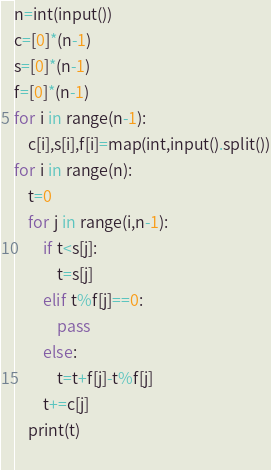Convert code to text. <code><loc_0><loc_0><loc_500><loc_500><_Python_>n=int(input())
c=[0]*(n-1)
s=[0]*(n-1)
f=[0]*(n-1)
for i in range(n-1):
    c[i],s[i],f[i]=map(int,input().split())
for i in range(n):
    t=0
    for j in range(i,n-1):
        if t<s[j]:
            t=s[j]
        elif t%f[j]==0:
            pass
        else:
            t=t+f[j]-t%f[j]
        t+=c[j]
    print(t)
    
</code> 